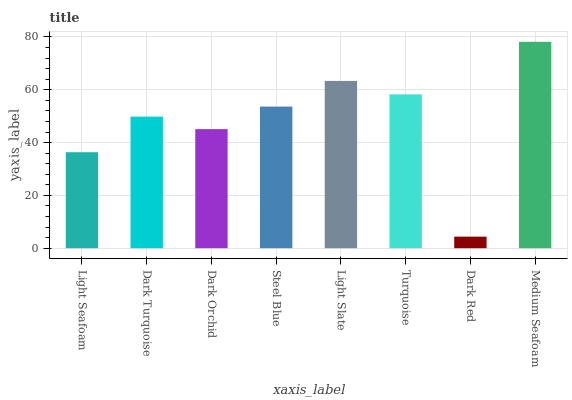Is Dark Red the minimum?
Answer yes or no. Yes. Is Medium Seafoam the maximum?
Answer yes or no. Yes. Is Dark Turquoise the minimum?
Answer yes or no. No. Is Dark Turquoise the maximum?
Answer yes or no. No. Is Dark Turquoise greater than Light Seafoam?
Answer yes or no. Yes. Is Light Seafoam less than Dark Turquoise?
Answer yes or no. Yes. Is Light Seafoam greater than Dark Turquoise?
Answer yes or no. No. Is Dark Turquoise less than Light Seafoam?
Answer yes or no. No. Is Steel Blue the high median?
Answer yes or no. Yes. Is Dark Turquoise the low median?
Answer yes or no. Yes. Is Medium Seafoam the high median?
Answer yes or no. No. Is Light Seafoam the low median?
Answer yes or no. No. 